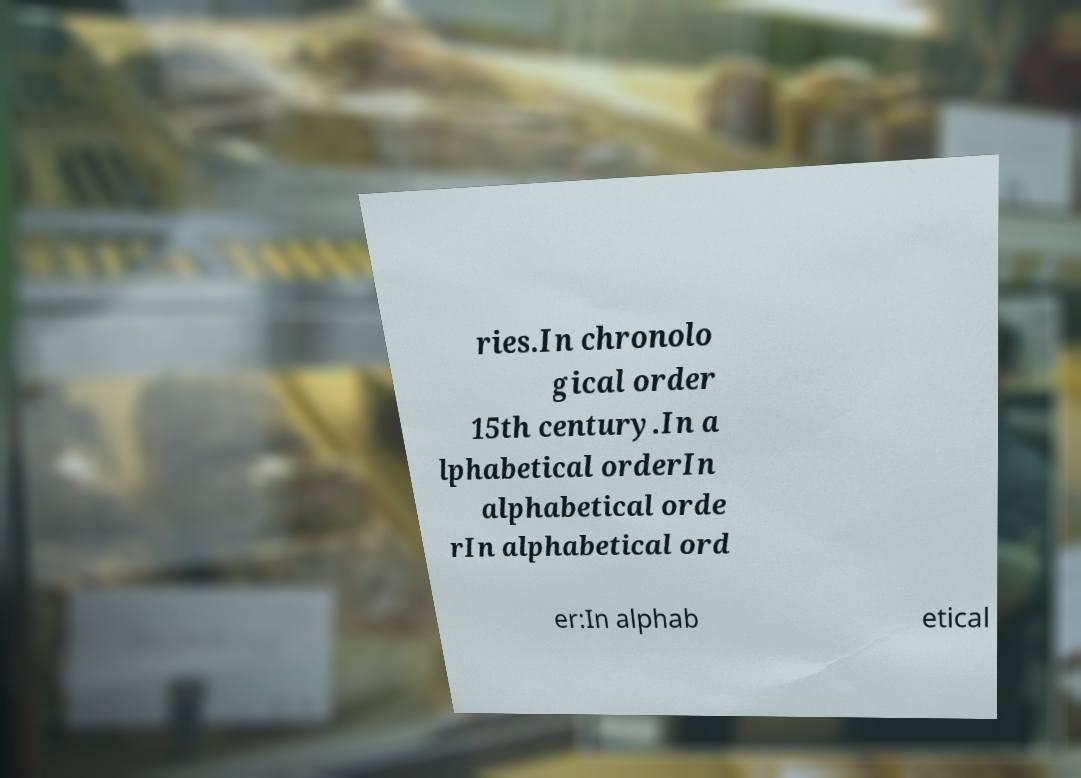What messages or text are displayed in this image? I need them in a readable, typed format. ries.In chronolo gical order 15th century.In a lphabetical orderIn alphabetical orde rIn alphabetical ord er:In alphab etical 